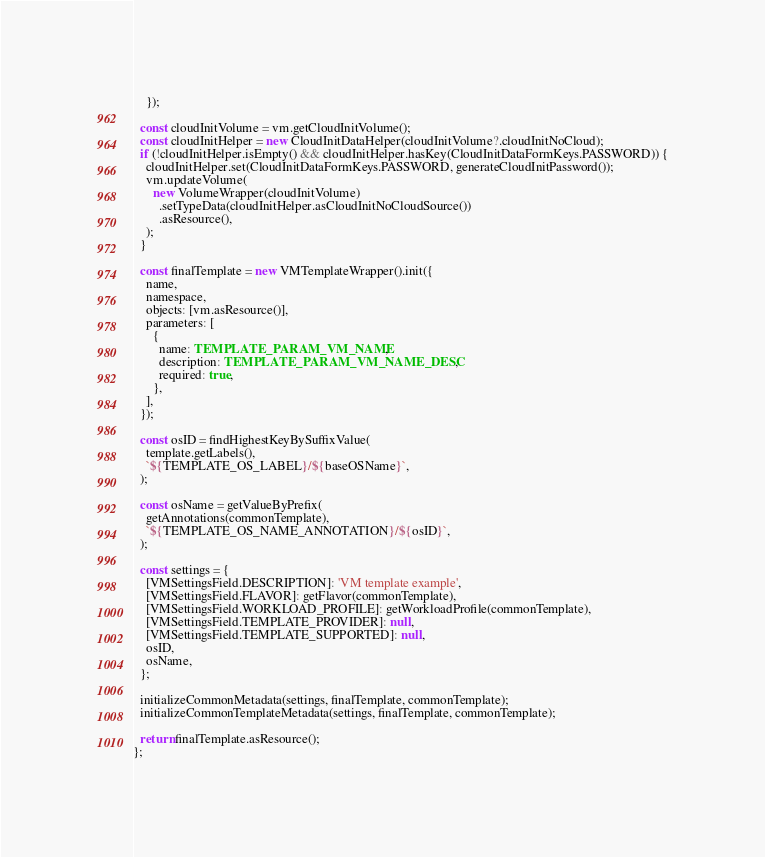<code> <loc_0><loc_0><loc_500><loc_500><_TypeScript_>    });

  const cloudInitVolume = vm.getCloudInitVolume();
  const cloudInitHelper = new CloudInitDataHelper(cloudInitVolume?.cloudInitNoCloud);
  if (!cloudInitHelper.isEmpty() && cloudInitHelper.hasKey(CloudInitDataFormKeys.PASSWORD)) {
    cloudInitHelper.set(CloudInitDataFormKeys.PASSWORD, generateCloudInitPassword());
    vm.updateVolume(
      new VolumeWrapper(cloudInitVolume)
        .setTypeData(cloudInitHelper.asCloudInitNoCloudSource())
        .asResource(),
    );
  }

  const finalTemplate = new VMTemplateWrapper().init({
    name,
    namespace,
    objects: [vm.asResource()],
    parameters: [
      {
        name: TEMPLATE_PARAM_VM_NAME,
        description: TEMPLATE_PARAM_VM_NAME_DESC,
        required: true,
      },
    ],
  });

  const osID = findHighestKeyBySuffixValue(
    template.getLabels(),
    `${TEMPLATE_OS_LABEL}/${baseOSName}`,
  );

  const osName = getValueByPrefix(
    getAnnotations(commonTemplate),
    `${TEMPLATE_OS_NAME_ANNOTATION}/${osID}`,
  );

  const settings = {
    [VMSettingsField.DESCRIPTION]: 'VM template example',
    [VMSettingsField.FLAVOR]: getFlavor(commonTemplate),
    [VMSettingsField.WORKLOAD_PROFILE]: getWorkloadProfile(commonTemplate),
    [VMSettingsField.TEMPLATE_PROVIDER]: null,
    [VMSettingsField.TEMPLATE_SUPPORTED]: null,
    osID,
    osName,
  };

  initializeCommonMetadata(settings, finalTemplate, commonTemplate);
  initializeCommonTemplateMetadata(settings, finalTemplate, commonTemplate);

  return finalTemplate.asResource();
};
</code> 